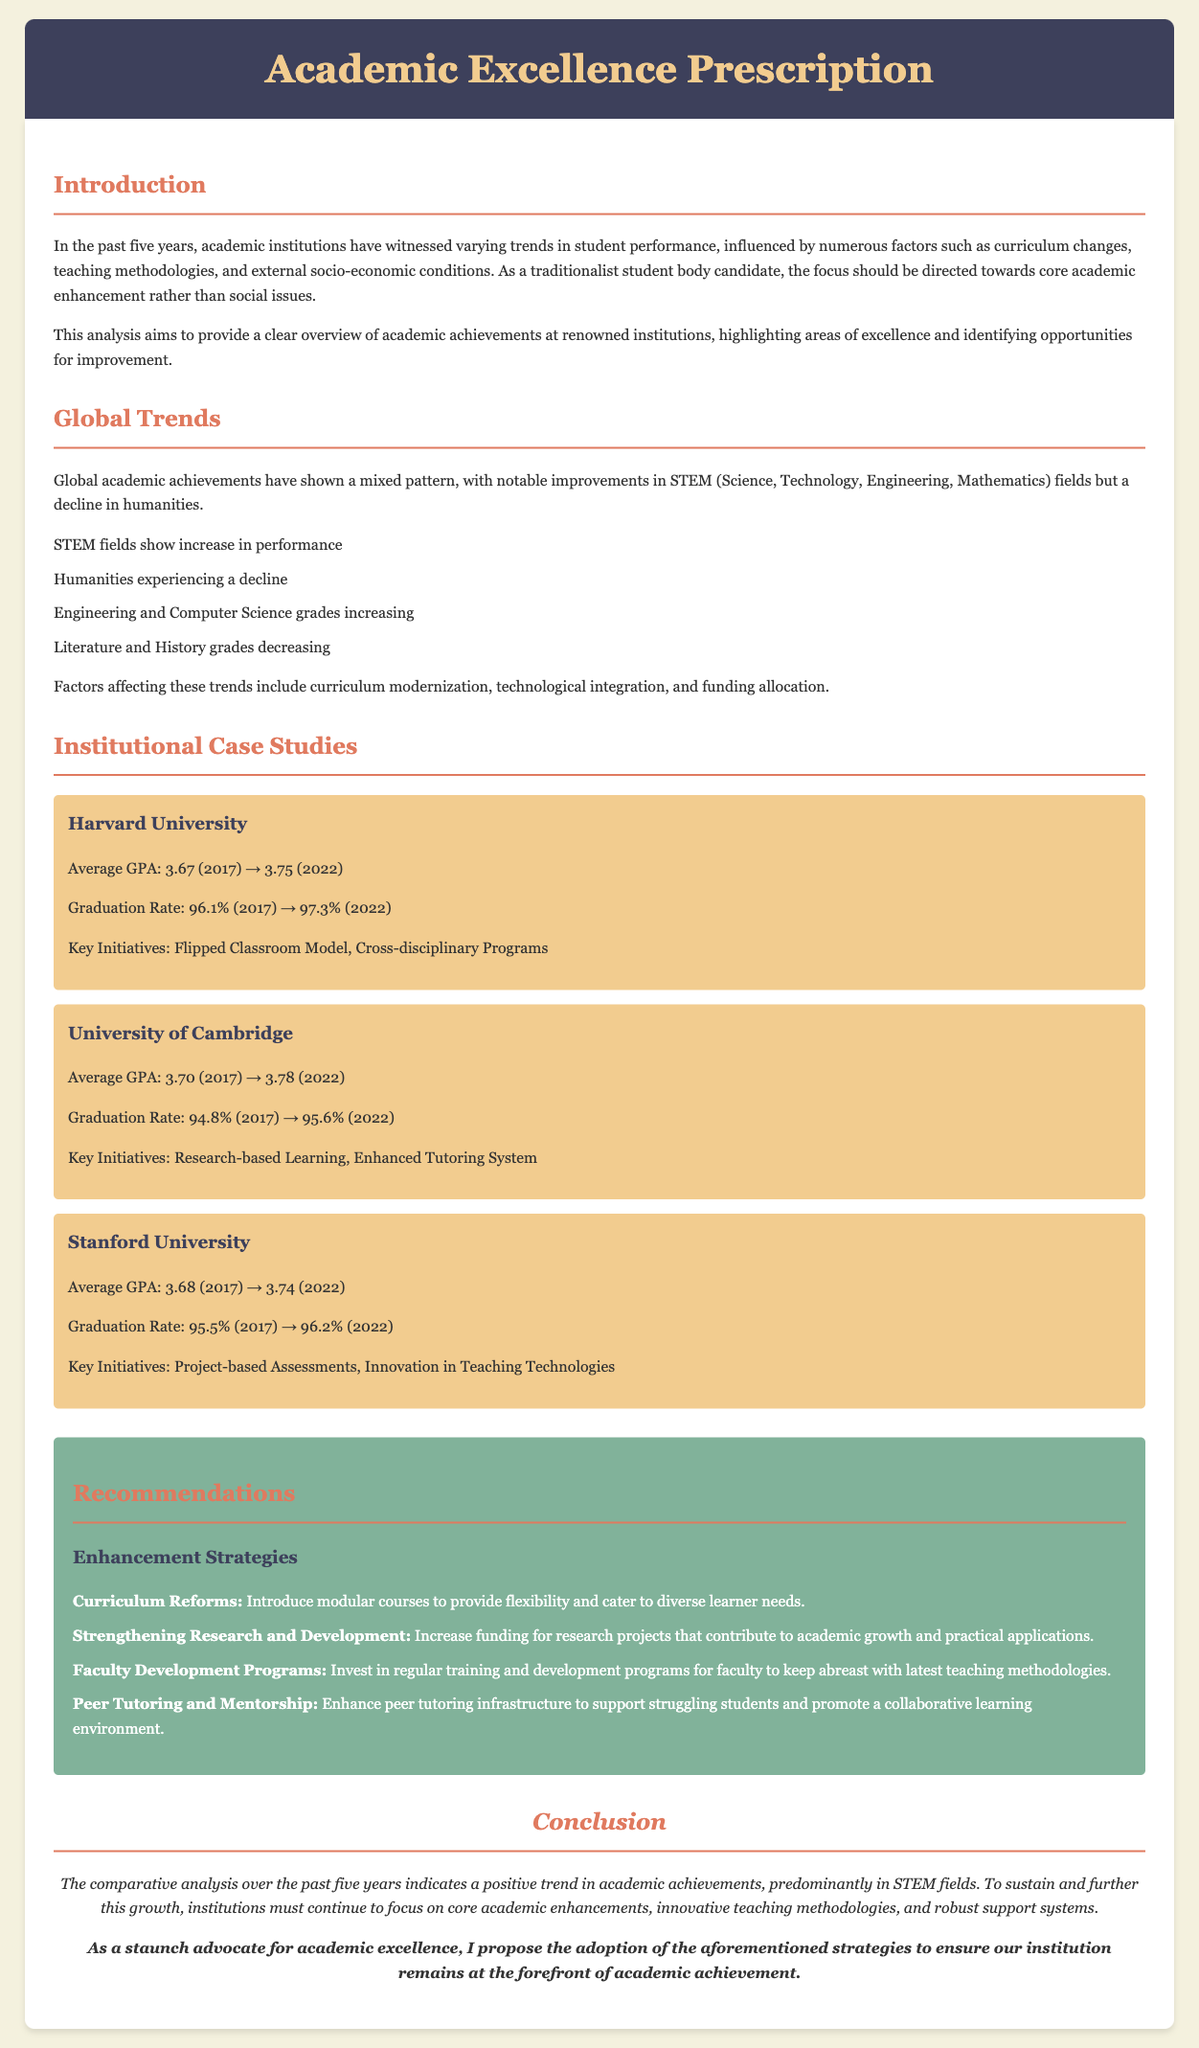What is the average GPA of Harvard University in 2022? The average GPA for Harvard University in 2022 is stated in the document.
Answer: 3.75 What was the graduation rate at the University of Cambridge in 2017? The graduation rate for the University of Cambridge in 2017 is explicitly mentioned in the document.
Answer: 94.8% Which field showed an increase in performance according to global trends? The document indicates that STEM fields are showing an increase in performance.
Answer: STEM What is one key initiative implemented at Stanford University? The document lists key initiatives for Stanford University, one of which is mentioned here.
Answer: Project-based Assessments What recommendation is made for faculty development? The document suggests faculty development programs as a strategy for improvement.
Answer: Regular training programs What trend is noted in humanities performance? The document reports a decline in humanities performance over the past five years.
Answer: Decline What is the graduation rate at Harvard University in 2022? The document specifies the graduation rate for Harvard University in the year 2022.
Answer: 97.3% What are the core focus areas listed for academic enhancement? The document emphasizes the importance of core academic enhancements, which can be derived from several sections.
Answer: Innovative teaching methodologies What strategy is proposed for peer tutoring? The document includes a strategy aimed at enhancing peer tutoring infrastructure.
Answer: Collaborative learning environment 